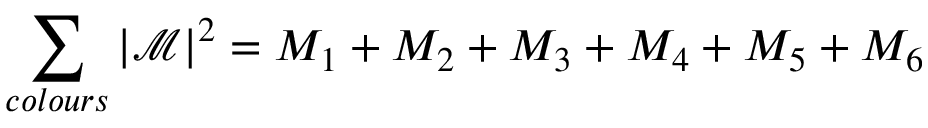<formula> <loc_0><loc_0><loc_500><loc_500>\sum _ { c o l o u r s } | \mathcal { M } | ^ { 2 } = M _ { 1 } + M _ { 2 } + M _ { 3 } + M _ { 4 } + M _ { 5 } + M _ { 6 }</formula> 